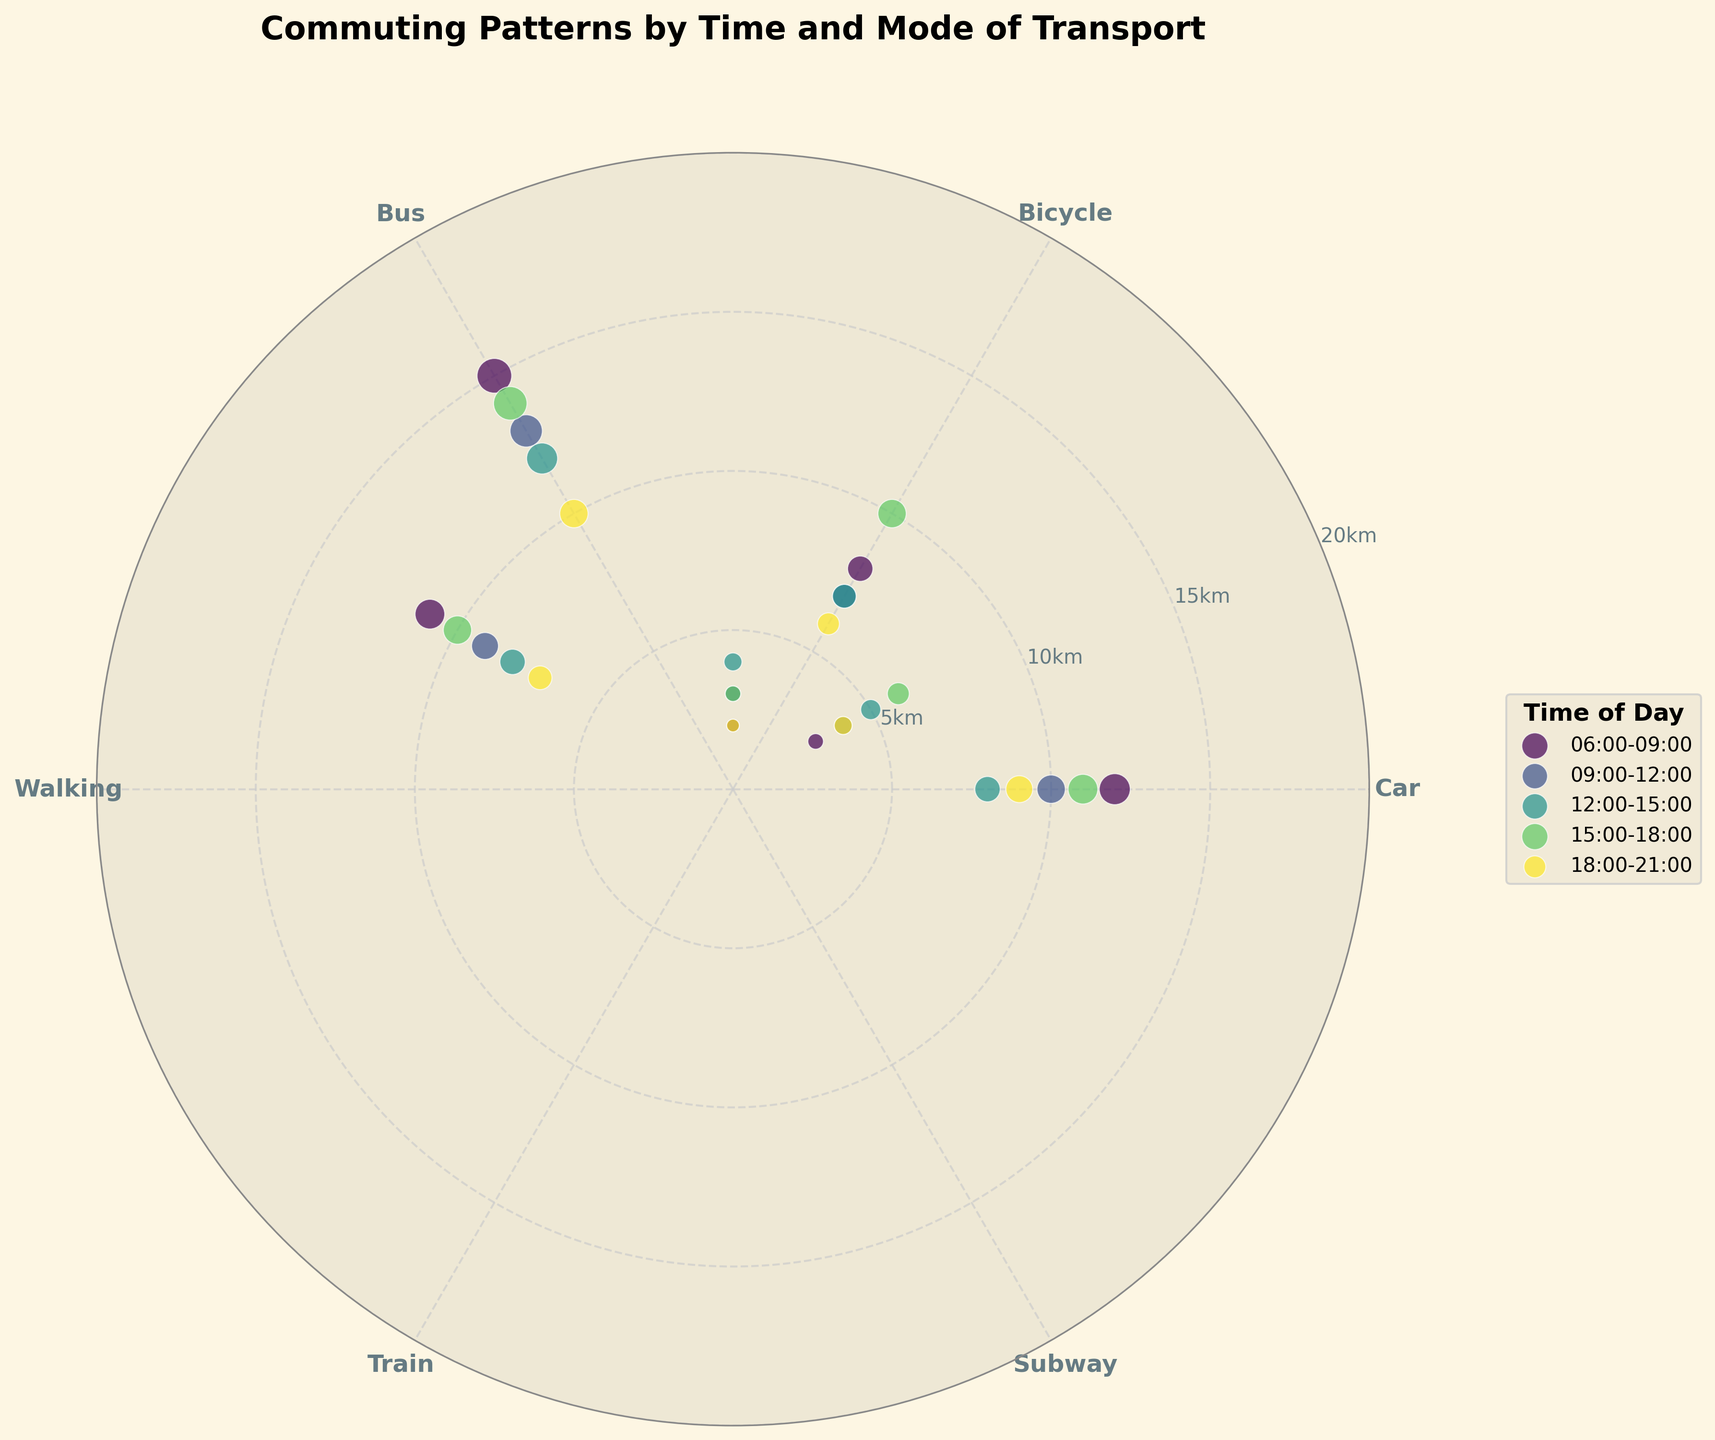Which time period is represented by the color pattern that is lightest on the plot? The lightest color on the plot corresponds to one of the time periods. Observing the legend, we see that the lightest color is associated with the time period of 09:00-12:00.
Answer: 09:00-12:00 What is the maximum distance for the “Car” mode of transport? Locate the 'Car' sector on the plot and observe the distances marked for each time period. We can see the outermost point, representing the longest distance, is 12 km for the 06:00-09:00 time period.
Answer: 12 km Which mode of transport has the smallest distance recorded in the 15:00-18:00 time period? For the 15:00-18:00 segment, check the points within the time period for the smallest distance. The smallest distance is observed for 'Walking,' which is 3 km.
Answer: Walking What average distance is travelled by bus between 06:00 and 18:00? We need to calculate the average distance for the 'Bus' mode of transport within 06:00-18:00. Adding the distances: 8 (06:00-09:00), 7 (09:00-12:00), 7 (12:00-15:00), and 10 (15:00-18:00). The sum is 32, and the average is 32/4 = 8 km.
Answer: 8 km Between the modes of transport 'Train' and 'Subway', which one shows a higher maximum distance? Compare the maximum distances for 'Train' and 'Subway'. The maximum for 'Train' is 15 km (06:00-09:00), and for 'Subway' it is 11 km within the same time. 'Train' thus shows the higher maximum distance.
Answer: Train During the 18:00-21:00 period, what is the difference in distance between the 'Car' and 'Bus' mode of transport? Find the distances for both 'Car' and 'Bus' within the 18:00-21:00 period. 'Car' has a distance of 9 km and 'Bus' has 6 km. The difference is 9 - 6 = 3 km.
Answer: 3 km For the full day, which time period shows the longest average commuting distance by any mode of transport? Calculate the average distance for all modes within each time period, then compare. Summing up for each time period and dividing by the number of transport modes determines that the highest average distance is during 06:00-09:00 with a high maximum value of 15 km for 'Train'.
Answer: 06:00-09:00 Is there any mode of transportation that has the same distance at two different times of day? By closely comparing each mode of transport across time periods, we find 'Bus' has a distance of 7 km at both 09:00-12:00 and 12:00-15:00.
Answer: Bus What is the total distance travelled by Bicyle across all the time periods displayed? Sum the distances for 'Bicycle' across each time period: 3 (06:00-09:00), 4 (09:00-12:00), 5 (12:00-15:00), and 6 (15:00-18:00), and 4 (18:00-21:00). Total is 3 + 4 + 5 + 6 + 4 = 22 km.
Answer: 22 km 